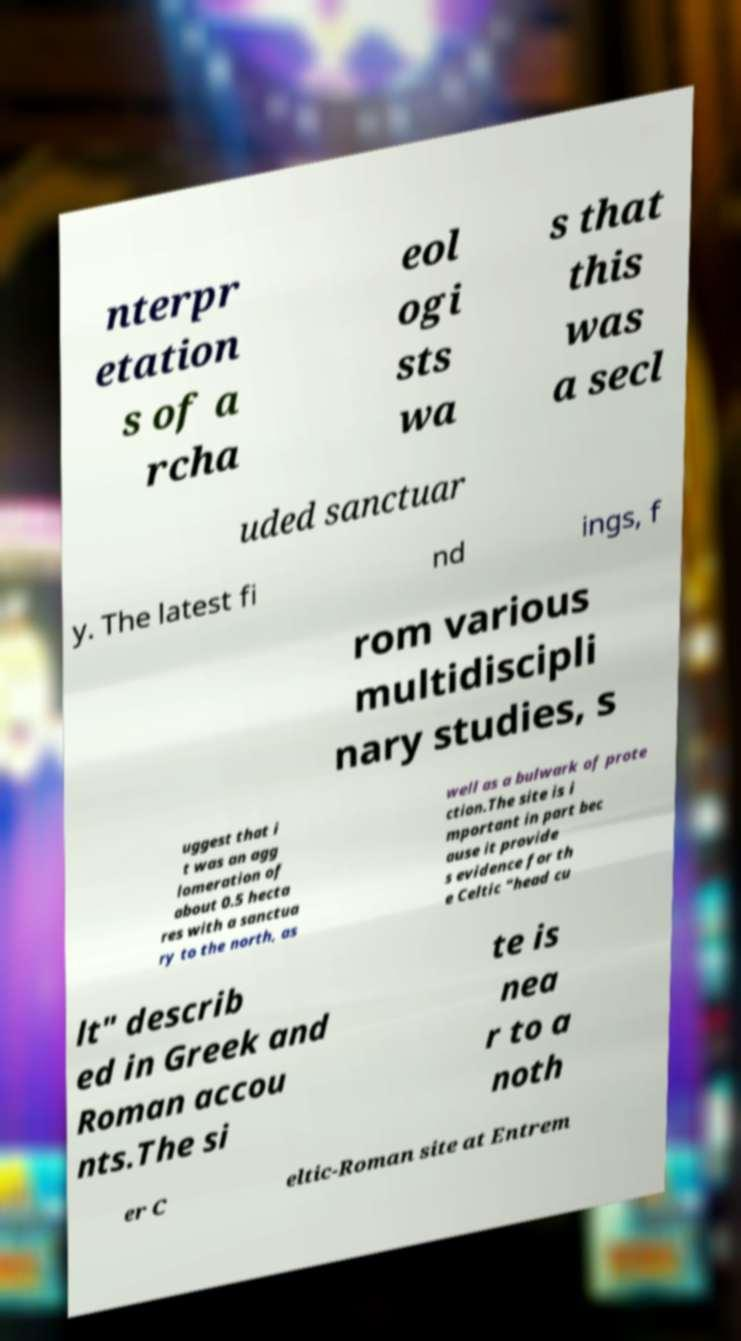Could you assist in decoding the text presented in this image and type it out clearly? nterpr etation s of a rcha eol ogi sts wa s that this was a secl uded sanctuar y. The latest fi nd ings, f rom various multidiscipli nary studies, s uggest that i t was an agg lomeration of about 0.5 hecta res with a sanctua ry to the north, as well as a bulwark of prote ction.The site is i mportant in part bec ause it provide s evidence for th e Celtic "head cu lt" describ ed in Greek and Roman accou nts.The si te is nea r to a noth er C eltic-Roman site at Entrem 